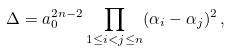<formula> <loc_0><loc_0><loc_500><loc_500>\Delta = a _ { 0 } ^ { 2 n - 2 } \prod _ { 1 \leq i < j \leq n } ( \alpha _ { i } - \alpha _ { j } ) ^ { 2 } \, ,</formula> 